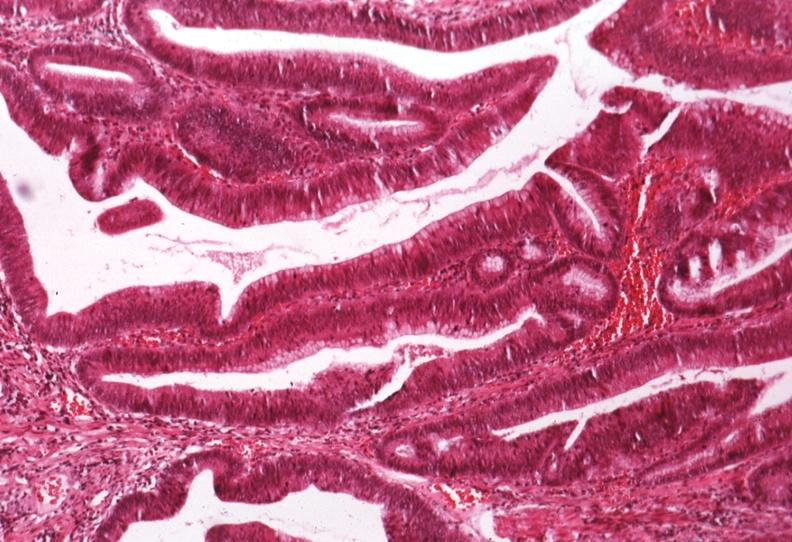what is present?
Answer the question using a single word or phrase. Gastrointestinal 